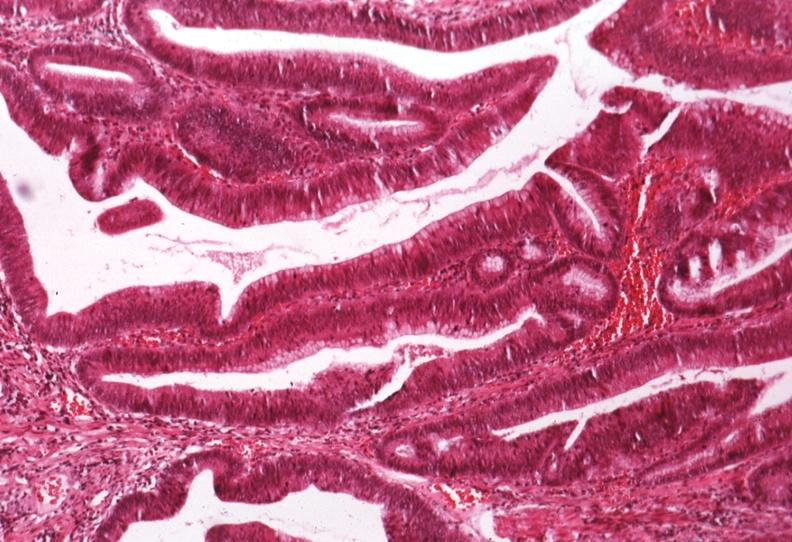what is present?
Answer the question using a single word or phrase. Gastrointestinal 